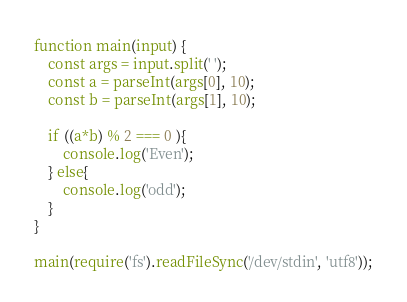Convert code to text. <code><loc_0><loc_0><loc_500><loc_500><_JavaScript_>function main(input) {
    const args = input.split(' ');
    const a = parseInt(args[0], 10);
    const b = parseInt(args[1], 10);

    if ((a*b) % 2 === 0 ){
        console.log('Even');
    } else{
        console.log('odd');
    }
}

main(require('fs').readFileSync('/dev/stdin', 'utf8'));</code> 